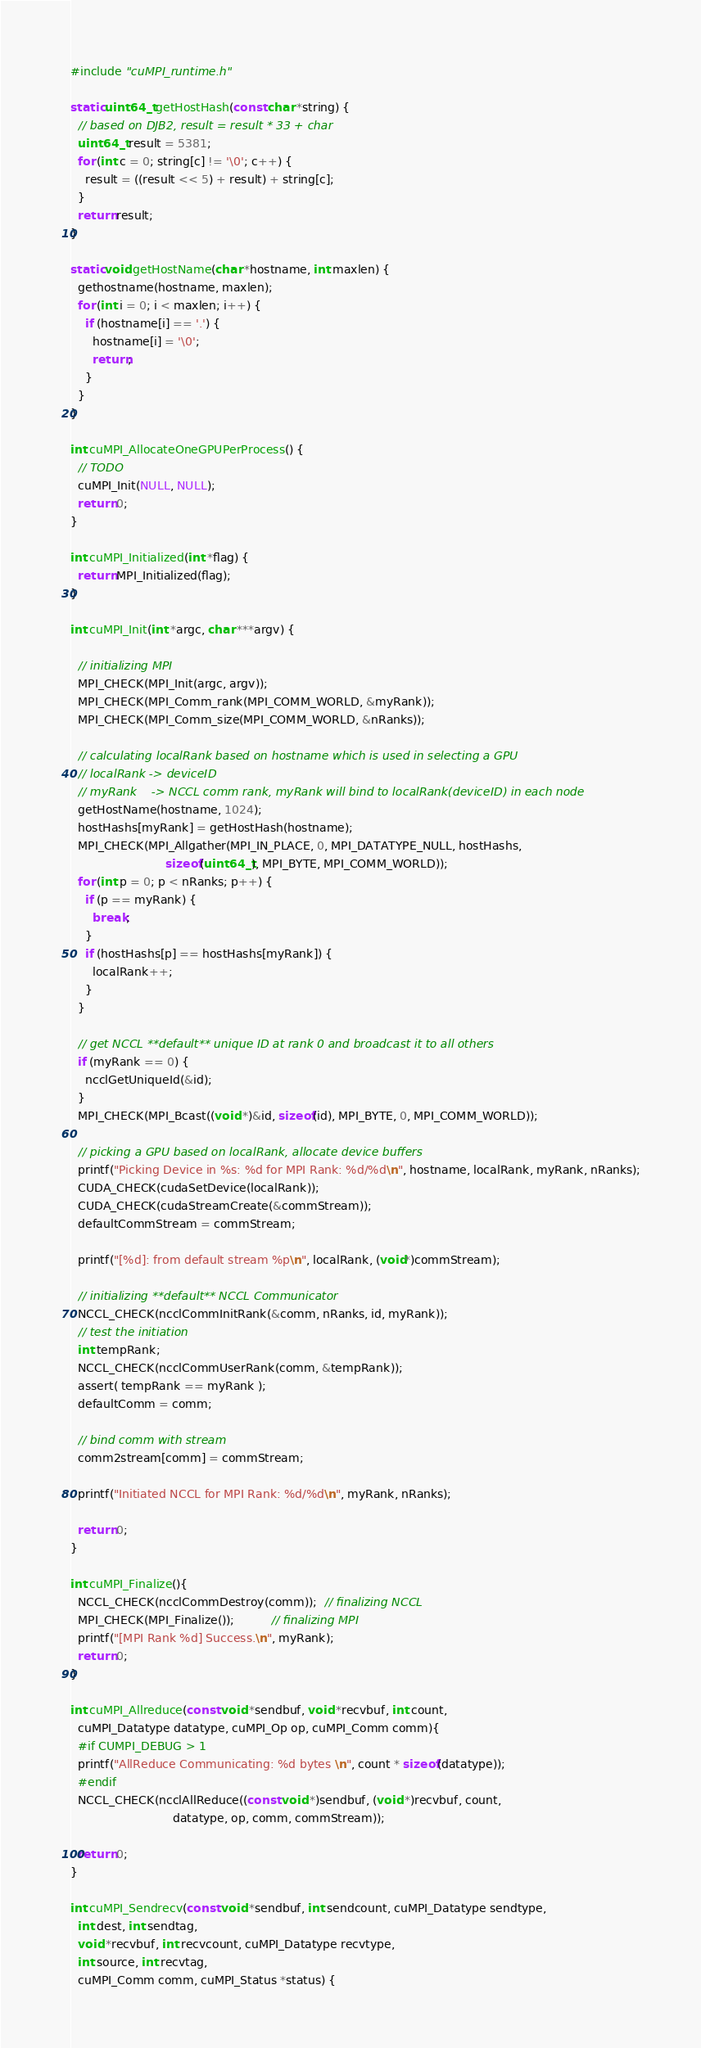<code> <loc_0><loc_0><loc_500><loc_500><_Cuda_>#include "cuMPI_runtime.h"

static uint64_t getHostHash(const char *string) {
  // based on DJB2, result = result * 33 + char
  uint64_t result = 5381;
  for (int c = 0; string[c] != '\0'; c++) {
    result = ((result << 5) + result) + string[c];
  }
  return result;
}

static void getHostName(char *hostname, int maxlen) {
  gethostname(hostname, maxlen);
  for (int i = 0; i < maxlen; i++) {
    if (hostname[i] == '.') {
      hostname[i] = '\0';
      return;
    }
  }
}

int cuMPI_AllocateOneGPUPerProcess() {
  // TODO
  cuMPI_Init(NULL, NULL);
  return 0;
}

int cuMPI_Initialized(int *flag) { 
  return MPI_Initialized(flag);
}

int cuMPI_Init(int *argc, char ***argv) {

  // initializing MPI
  MPI_CHECK(MPI_Init(argc, argv));
  MPI_CHECK(MPI_Comm_rank(MPI_COMM_WORLD, &myRank));
  MPI_CHECK(MPI_Comm_size(MPI_COMM_WORLD, &nRanks));

  // calculating localRank based on hostname which is used in selecting a GPU
  // localRank -> deviceID
  // myRank    -> NCCL comm rank, myRank will bind to localRank(deviceID) in each node
  getHostName(hostname, 1024);
  hostHashs[myRank] = getHostHash(hostname);
  MPI_CHECK(MPI_Allgather(MPI_IN_PLACE, 0, MPI_DATATYPE_NULL, hostHashs,
                          sizeof(uint64_t), MPI_BYTE, MPI_COMM_WORLD));
  for (int p = 0; p < nRanks; p++) {
    if (p == myRank) {
      break;
    }
    if (hostHashs[p] == hostHashs[myRank]) {
      localRank++;
    }
  }

  // get NCCL **default** unique ID at rank 0 and broadcast it to all others
  if (myRank == 0) {
    ncclGetUniqueId(&id);
  }
  MPI_CHECK(MPI_Bcast((void *)&id, sizeof(id), MPI_BYTE, 0, MPI_COMM_WORLD));

  // picking a GPU based on localRank, allocate device buffers
  printf("Picking Device in %s: %d for MPI Rank: %d/%d\n", hostname, localRank, myRank, nRanks);
  CUDA_CHECK(cudaSetDevice(localRank));
  CUDA_CHECK(cudaStreamCreate(&commStream));
  defaultCommStream = commStream;

  printf("[%d]: from default stream %p\n", localRank, (void*)commStream);

  // initializing **default** NCCL Communicator
  NCCL_CHECK(ncclCommInitRank(&comm, nRanks, id, myRank));
  // test the initiation
  int tempRank;
  NCCL_CHECK(ncclCommUserRank(comm, &tempRank));
  assert( tempRank == myRank );
  defaultComm = comm;

  // bind comm with stream
  comm2stream[comm] = commStream;

  printf("Initiated NCCL for MPI Rank: %d/%d\n", myRank, nRanks);

  return 0;
}

int cuMPI_Finalize(){
  NCCL_CHECK(ncclCommDestroy(comm));  // finalizing NCCL
  MPI_CHECK(MPI_Finalize());          // finalizing MPI
  printf("[MPI Rank %d] Success.\n", myRank);
  return 0;
}

int cuMPI_Allreduce(const void *sendbuf, void *recvbuf, int count,
  cuMPI_Datatype datatype, cuMPI_Op op, cuMPI_Comm comm){
  #if CUMPI_DEBUG > 1
  printf("AllReduce Communicating: %d bytes \n", count * sizeof(datatype));
  #endif
  NCCL_CHECK(ncclAllReduce((const void *)sendbuf, (void *)recvbuf, count,
                            datatype, op, comm, commStream));

  return 0;
}

int cuMPI_Sendrecv(const void *sendbuf, int sendcount, cuMPI_Datatype sendtype,
  int dest, int sendtag,
  void *recvbuf, int recvcount, cuMPI_Datatype recvtype,
  int source, int recvtag,
  cuMPI_Comm comm, cuMPI_Status *status) {</code> 